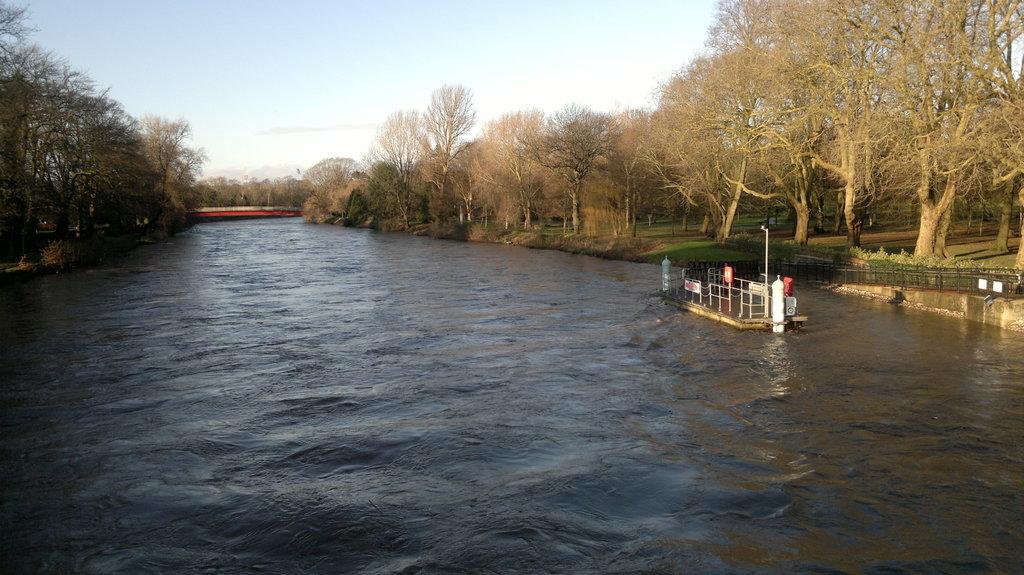What is the primary element flowing in the image? There is water flowing in the image. What structures are present in the image to control or direct the flow of water? There are barricades in the image. What vertical object can be seen in the image? There is a pole in the image. What type of vegetation is present in the image? There are trees, branches, and small bushes in the image. What is the name of the food item being prepared in the image? There is no food item being prepared in the image; it primarily features water flowing and related structures. 